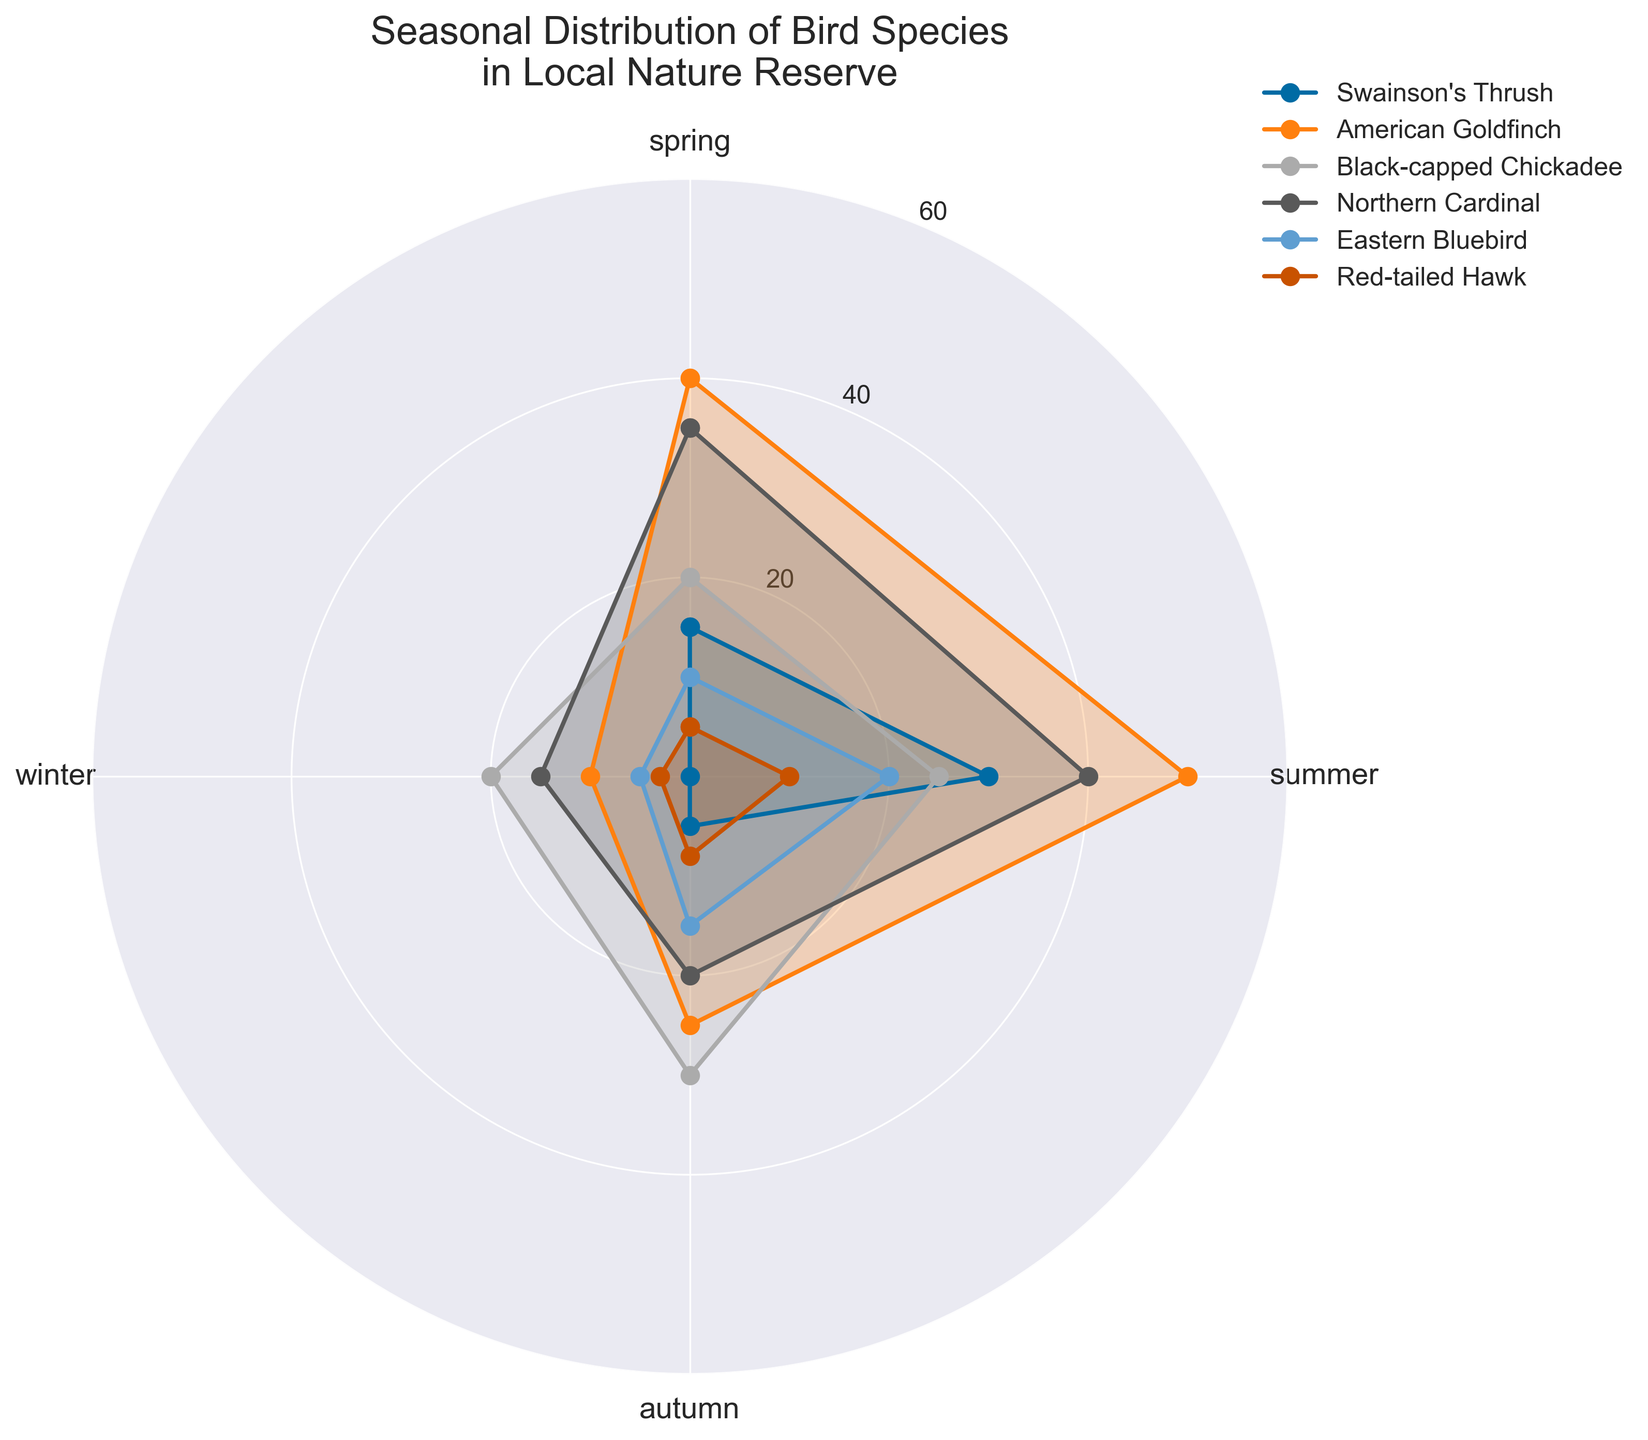Which bird species is observed in all four seasons? The species that appear in all four seasons can be found by looking at the plot where the respective lines are drawn throughout spring, summer, autumn, and winter sections.
Answer: Swainson's Thrush, American Goldfinch, Black-capped Chickadee, Northern Cardinal, Eastern Bluebird, Red-tailed Hawk During which season is the American Goldfinch most commonly observed? By looking at the segment where the American Goldfinch's line reaches the highest value, we can determine the season with the highest count. This is in the summer segment.
Answer: Summer Which species has the highest count in winter? To find this, we observe the values connected to the winter segment. The highest count value there will indicate the species. The count for American Goldfinch is 10, Northern Cardinal is 15, Black-capped Chickadee is 20, Eastern Bluebird is 5, Red-tailed Hawk is 3, and Swainson's Thrush is 0. Black-capped Chickadee has the highest count.
Answer: Black-capped Chickadee How does the count of Swainson's Thrush in summer compare to its count in autumn? We look at the values for Swainson's Thrush in the summer and autumn segments. This shows a comparison of 30 (summer) and 5 (autumn).
Answer: Summer count is higher What is the total number of American Goldfinches observed across all seasons? To find the total, we sum up the counts for American Goldfinch in each season: 40 (spring) + 50 (summer) + 25 (autumn) + 10 (winter) = 125.
Answer: 125 Which season has the lowest number of Red-tailed Hawks observed? Compare the segments for each season to see where the Red-tailed Hawk has its lowest count. Observing 5 (spring), 10 (summer), 8 (autumn), and 3 (winter), winter is the lowest.
Answer: Winter What is the average count of Black-capped Chickadees across all seasons? First, sum the counts for Black-capped Chickadee in each season: 20 (spring) + 25 (summer) + 30 (autumn) + 20 (winter) = 95. Then divide by the number of seasons, which is 4. So, 95/4 = 23.75.
Answer: 23.75 Considering all species, which season has the highest total bird count? To determine this, sum the counts for all species in each season. For spring: 15 + 40 + 20 + 35 + 10 + 5 = 125; summer: 30 + 50 + 25 + 40 + 20 + 10 = 175; autumn: 5 + 25 + 30 + 20 + 15 + 8 = 103; winter: 0 + 10 + 20 + 15 + 5 + 3 = 53. Summer has the highest total.
Answer: Summer In which season is the difference between the counts of Northern Cardinal and Eastern Bluebird the smallest? To find this, compare the differences for each season. Spring: 35 - 10 = 25; Summer: 40 - 20 = 20; Autumn: 20 - 15 = 5; Winter: 15 - 5 = 10. The smallest difference is in the autumn.
Answer: Autumn How many more American Goldfinches are observed in summer than in winter? By subtracting the winter count for American Goldfinch from the summer count, we get the difference: 50 (summer) - 10 (winter) = 40.
Answer: 40 